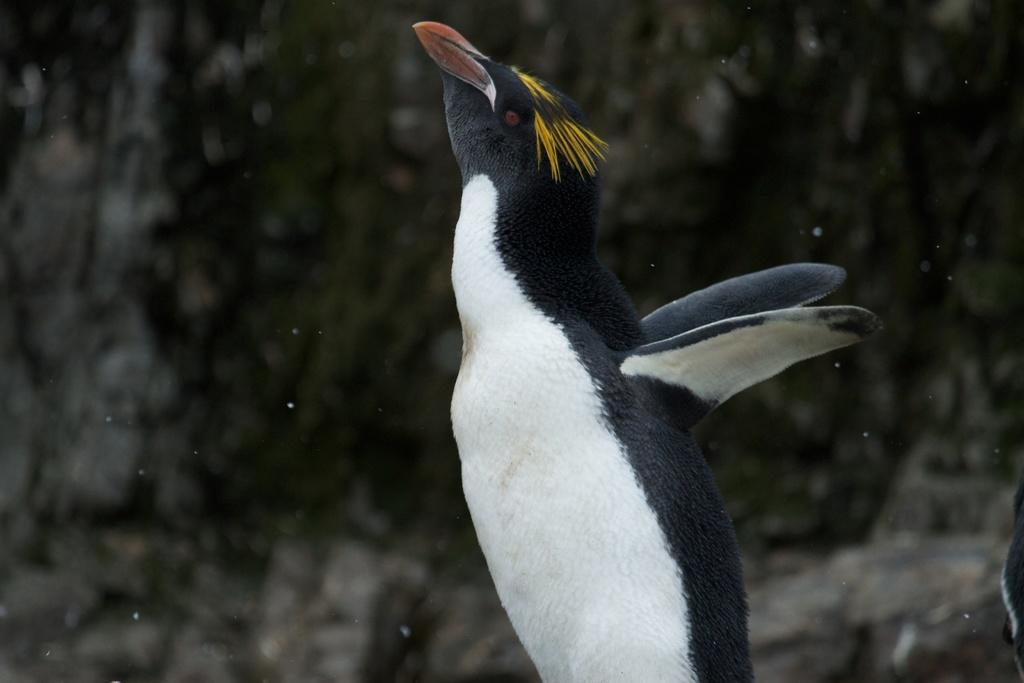What animal is present in the image? There is a penguin in the image. What is the penguin doing in the image? The penguin is standing in the image. What physical features does the penguin have? The penguin has wings and is black and white in color. Can you describe the background of the image? The background of the image appears blurry. What type of parent is the penguin meeting in the image? There is no meeting or parent present in the image; it features a penguin standing in a blurry background. How many deer can be seen in the image? There are no deer present in the image. 